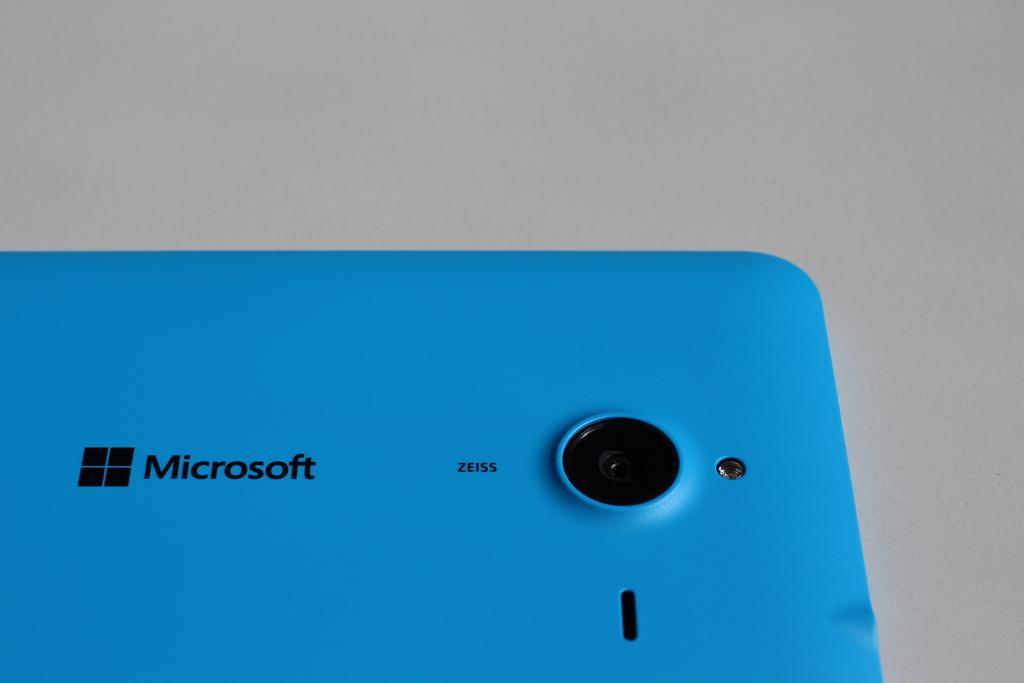Who is the manufacturer of the device?
Provide a succinct answer. Microsoft. What is the logo on the phone?
Offer a very short reply. Microsoft. 